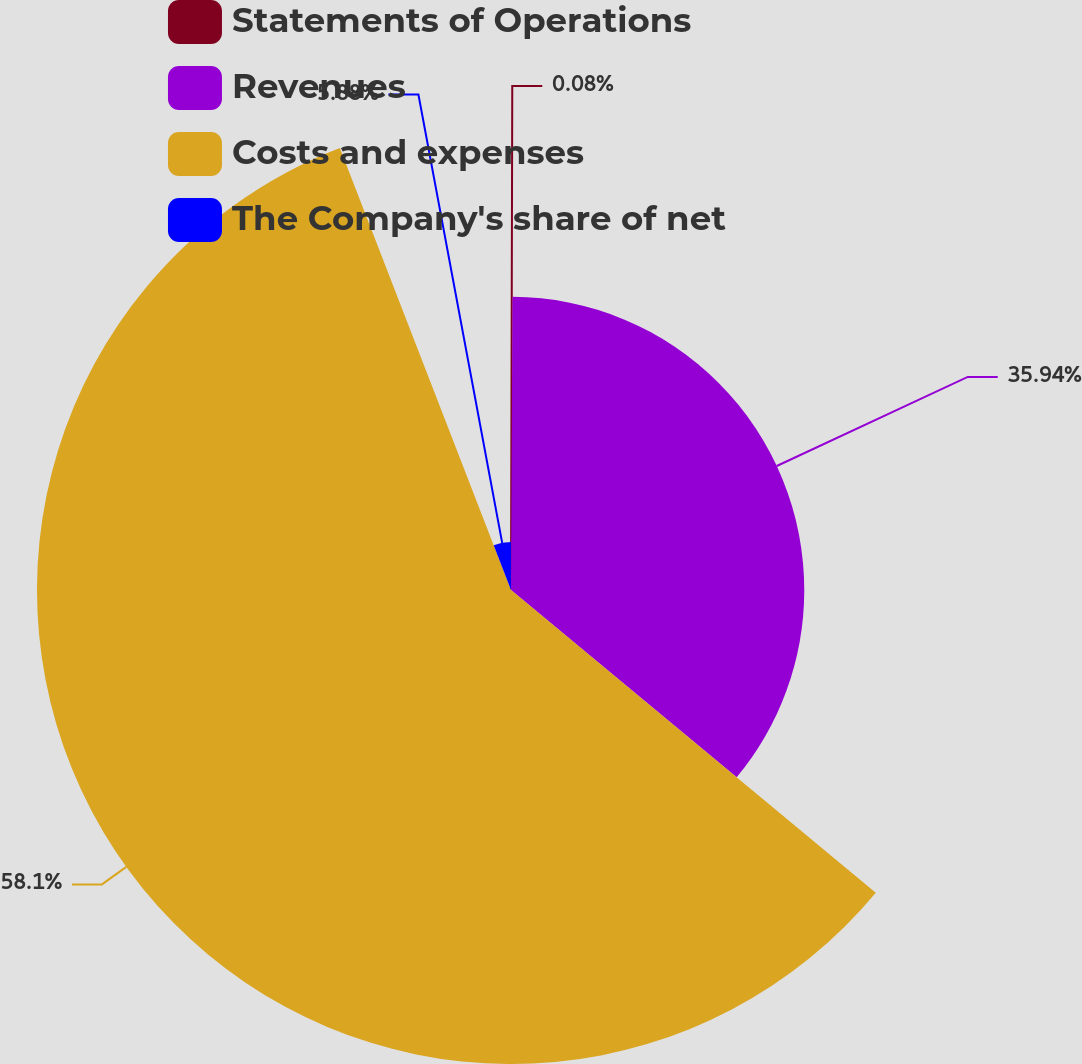Convert chart to OTSL. <chart><loc_0><loc_0><loc_500><loc_500><pie_chart><fcel>Statements of Operations<fcel>Revenues<fcel>Costs and expenses<fcel>The Company's share of net<nl><fcel>0.08%<fcel>35.94%<fcel>58.09%<fcel>5.88%<nl></chart> 